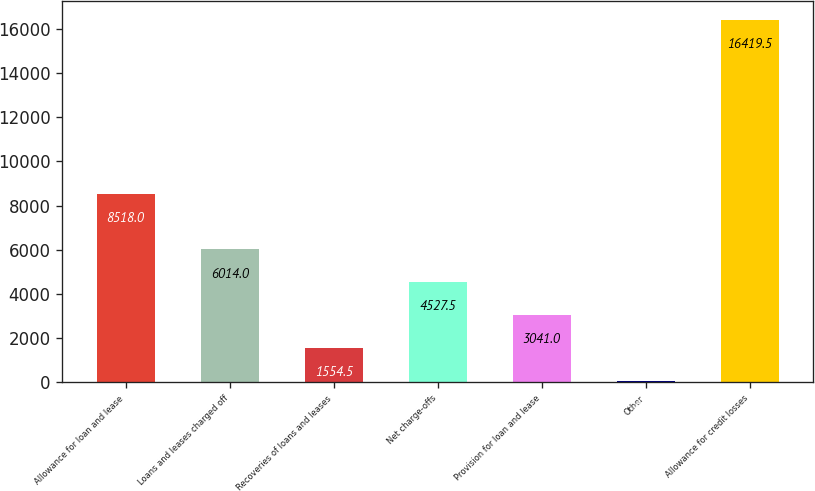<chart> <loc_0><loc_0><loc_500><loc_500><bar_chart><fcel>Allowance for loan and lease<fcel>Loans and leases charged off<fcel>Recoveries of loans and leases<fcel>Net charge-offs<fcel>Provision for loan and lease<fcel>Other<fcel>Allowance for credit losses<nl><fcel>8518<fcel>6014<fcel>1554.5<fcel>4527.5<fcel>3041<fcel>68<fcel>16419.5<nl></chart> 